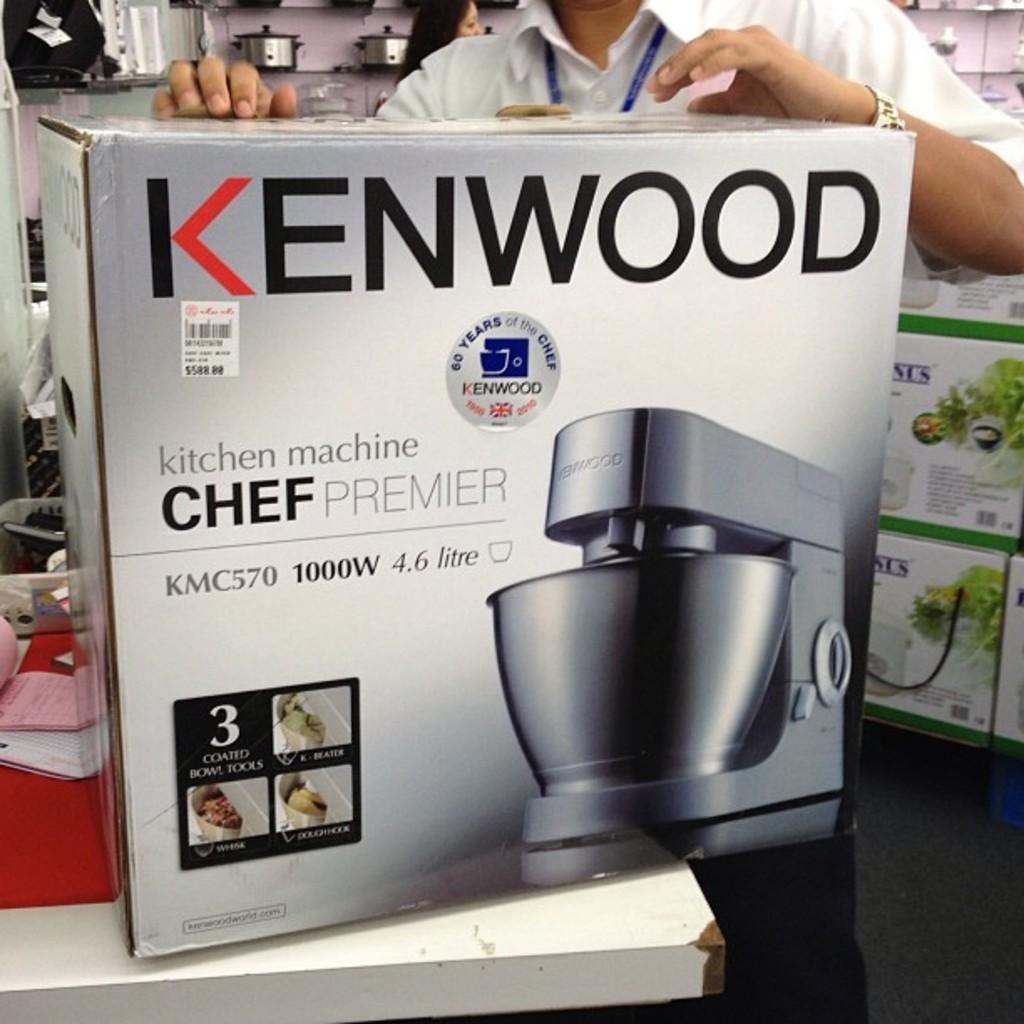What brand of kitchen machine is this?
Provide a succinct answer. Kenwood. 